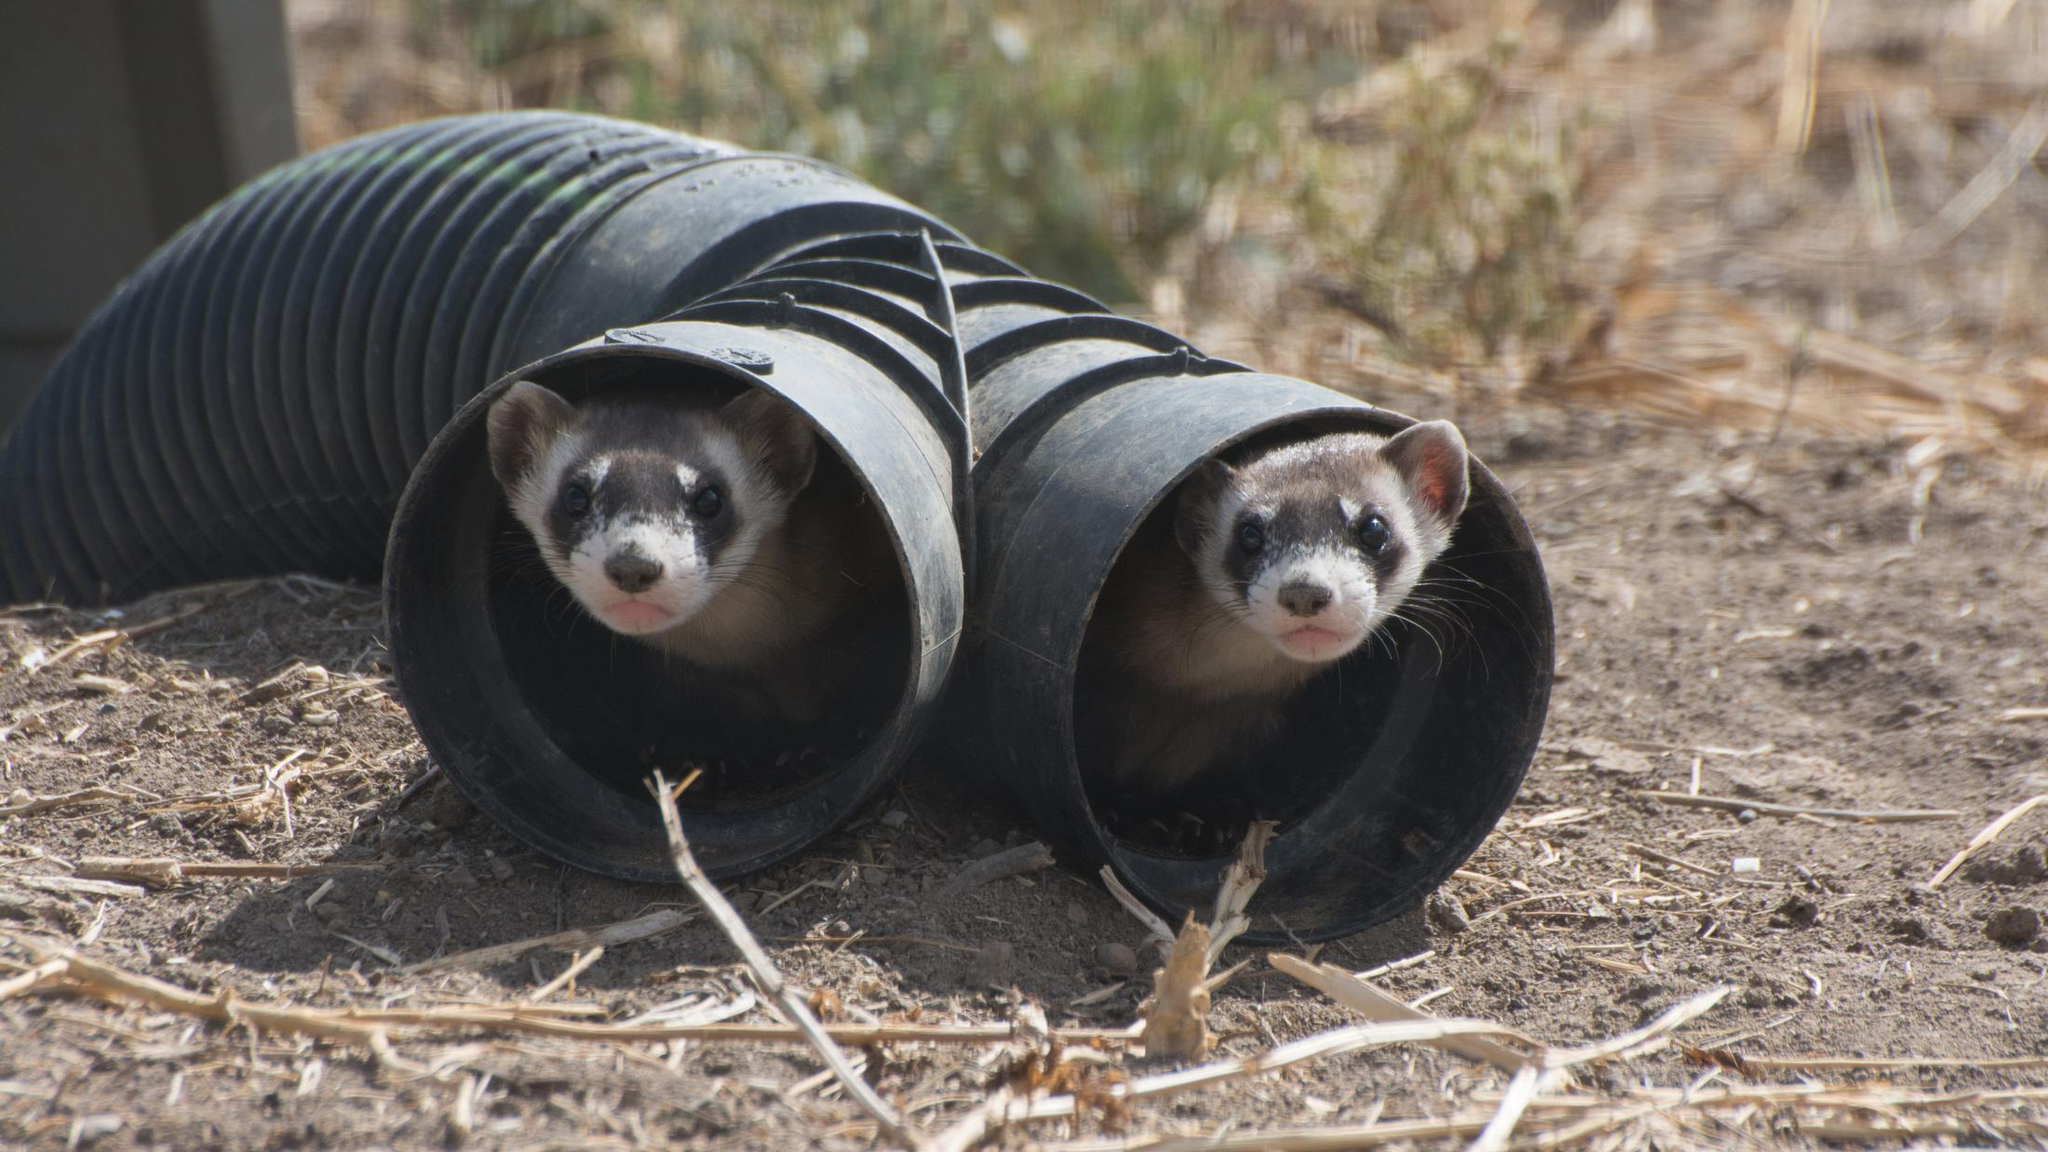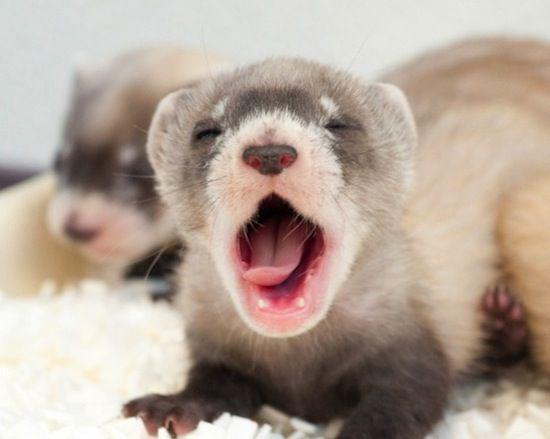The first image is the image on the left, the second image is the image on the right. Given the left and right images, does the statement "One image includes a ferret with closed eyes and open mouth on textured white bedding." hold true? Answer yes or no. Yes. 